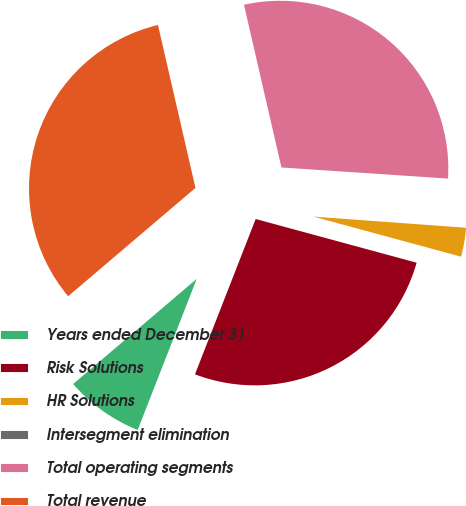Convert chart. <chart><loc_0><loc_0><loc_500><loc_500><pie_chart><fcel>Years ended December 31<fcel>Risk Solutions<fcel>HR Solutions<fcel>Intersegment elimination<fcel>Total operating segments<fcel>Total revenue<nl><fcel>7.85%<fcel>26.71%<fcel>3.06%<fcel>0.1%<fcel>29.66%<fcel>32.62%<nl></chart> 